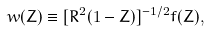<formula> <loc_0><loc_0><loc_500><loc_500>w ( Z ) \equiv [ R ^ { 2 } ( 1 - Z ) ] ^ { - 1 / 2 } f ( Z ) ,</formula> 